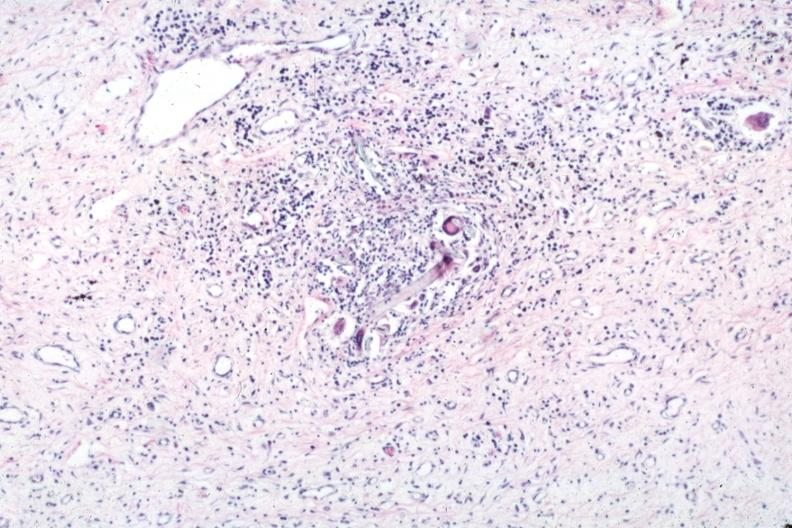s this photo present?
Answer the question using a single word or phrase. No 